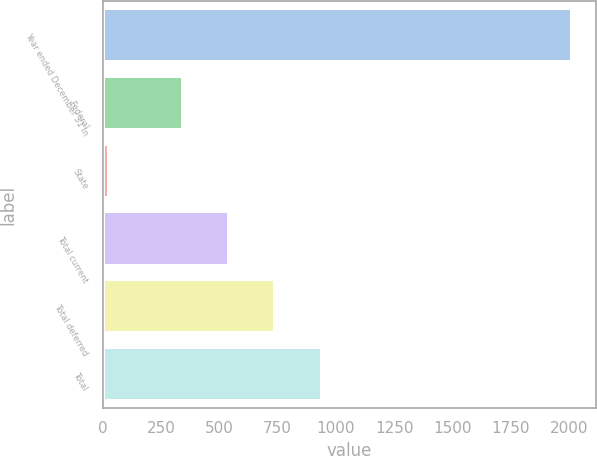Convert chart. <chart><loc_0><loc_0><loc_500><loc_500><bar_chart><fcel>Year ended December 31 In<fcel>Federal<fcel>State<fcel>Total current<fcel>Total deferred<fcel>Total<nl><fcel>2012<fcel>343<fcel>29<fcel>541.3<fcel>739.6<fcel>942<nl></chart> 